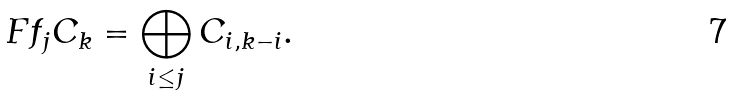Convert formula to latex. <formula><loc_0><loc_0><loc_500><loc_500>\ F f _ { j } C _ { k } = \bigoplus _ { i \leq j } C _ { i , k - i } .</formula> 